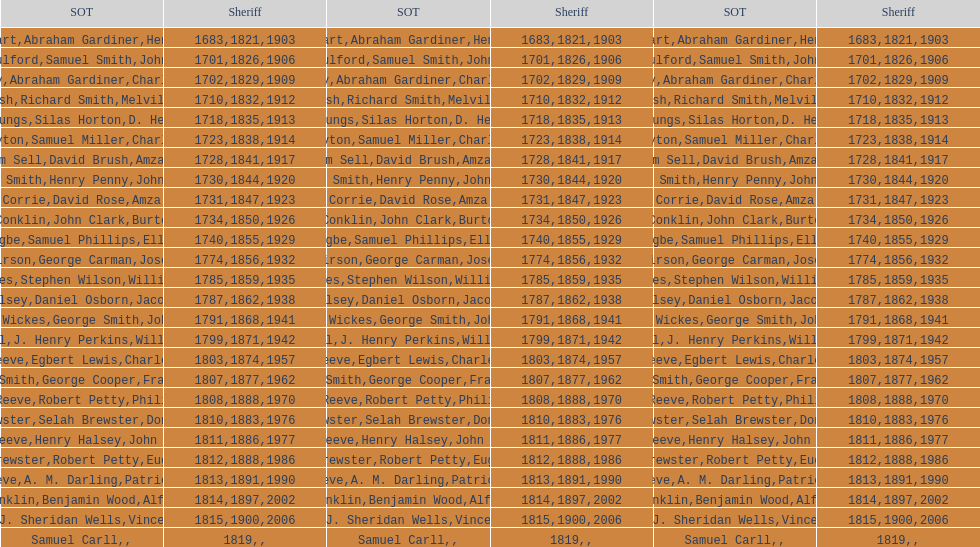Did robert petty serve before josiah reeve? No. 